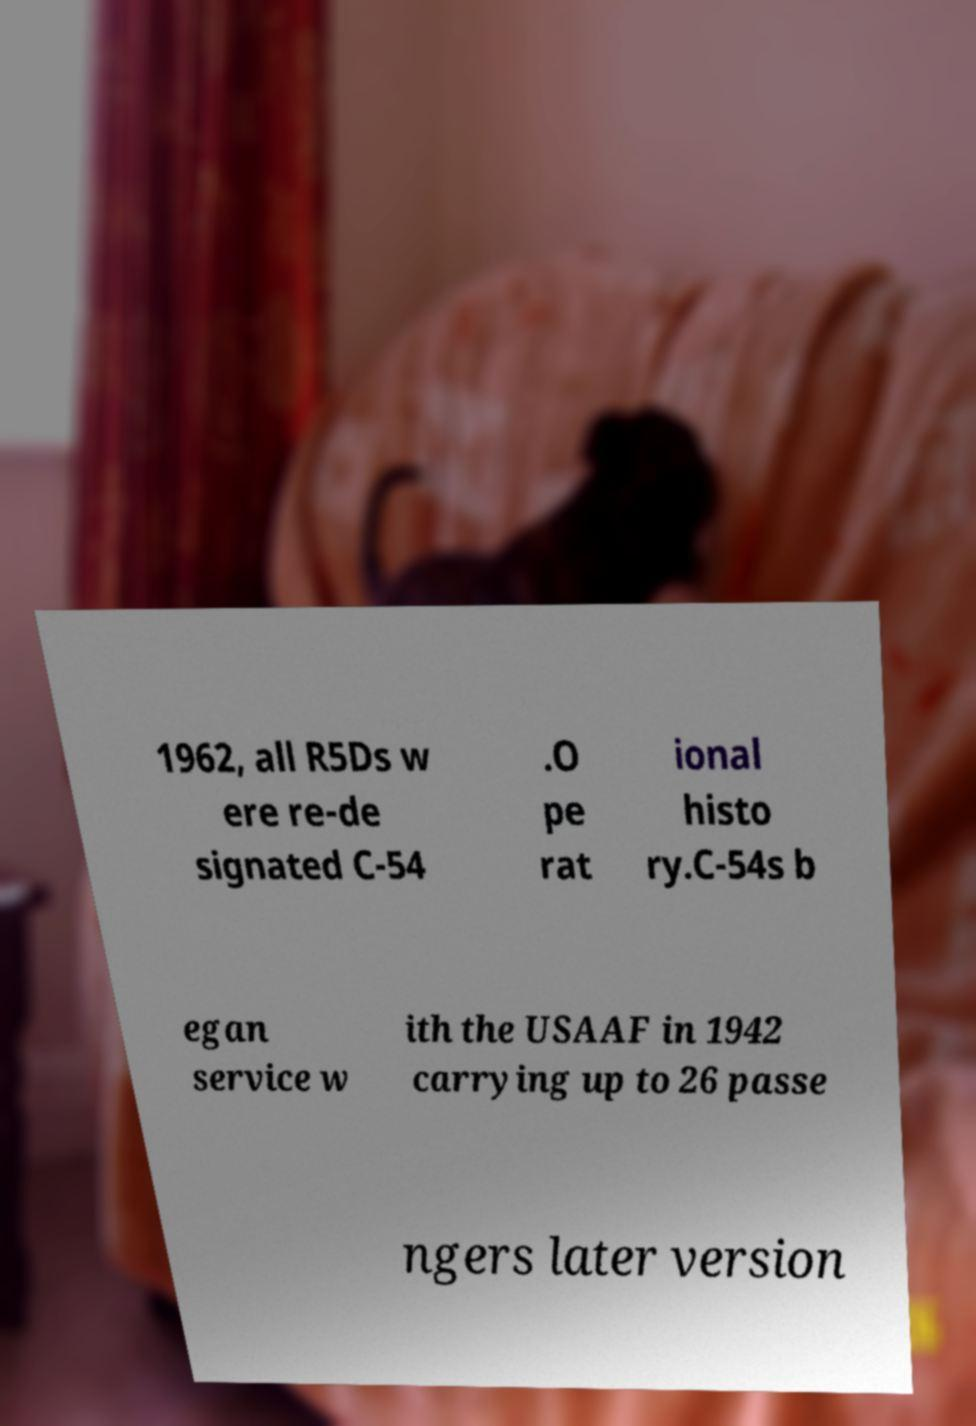Could you assist in decoding the text presented in this image and type it out clearly? 1962, all R5Ds w ere re-de signated C-54 .O pe rat ional histo ry.C-54s b egan service w ith the USAAF in 1942 carrying up to 26 passe ngers later version 